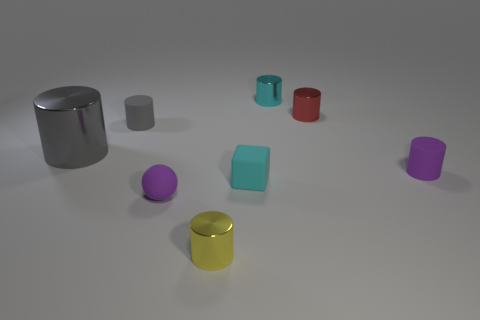Subtract 1 cylinders. How many cylinders are left? 5 Subtract all big cylinders. How many cylinders are left? 5 Subtract all purple cylinders. How many cylinders are left? 5 Subtract all yellow cylinders. Subtract all red cubes. How many cylinders are left? 5 Add 1 green shiny blocks. How many objects exist? 9 Subtract all spheres. How many objects are left? 7 Subtract 0 blue cylinders. How many objects are left? 8 Subtract all large brown cylinders. Subtract all balls. How many objects are left? 7 Add 2 red cylinders. How many red cylinders are left? 3 Add 3 cyan matte balls. How many cyan matte balls exist? 3 